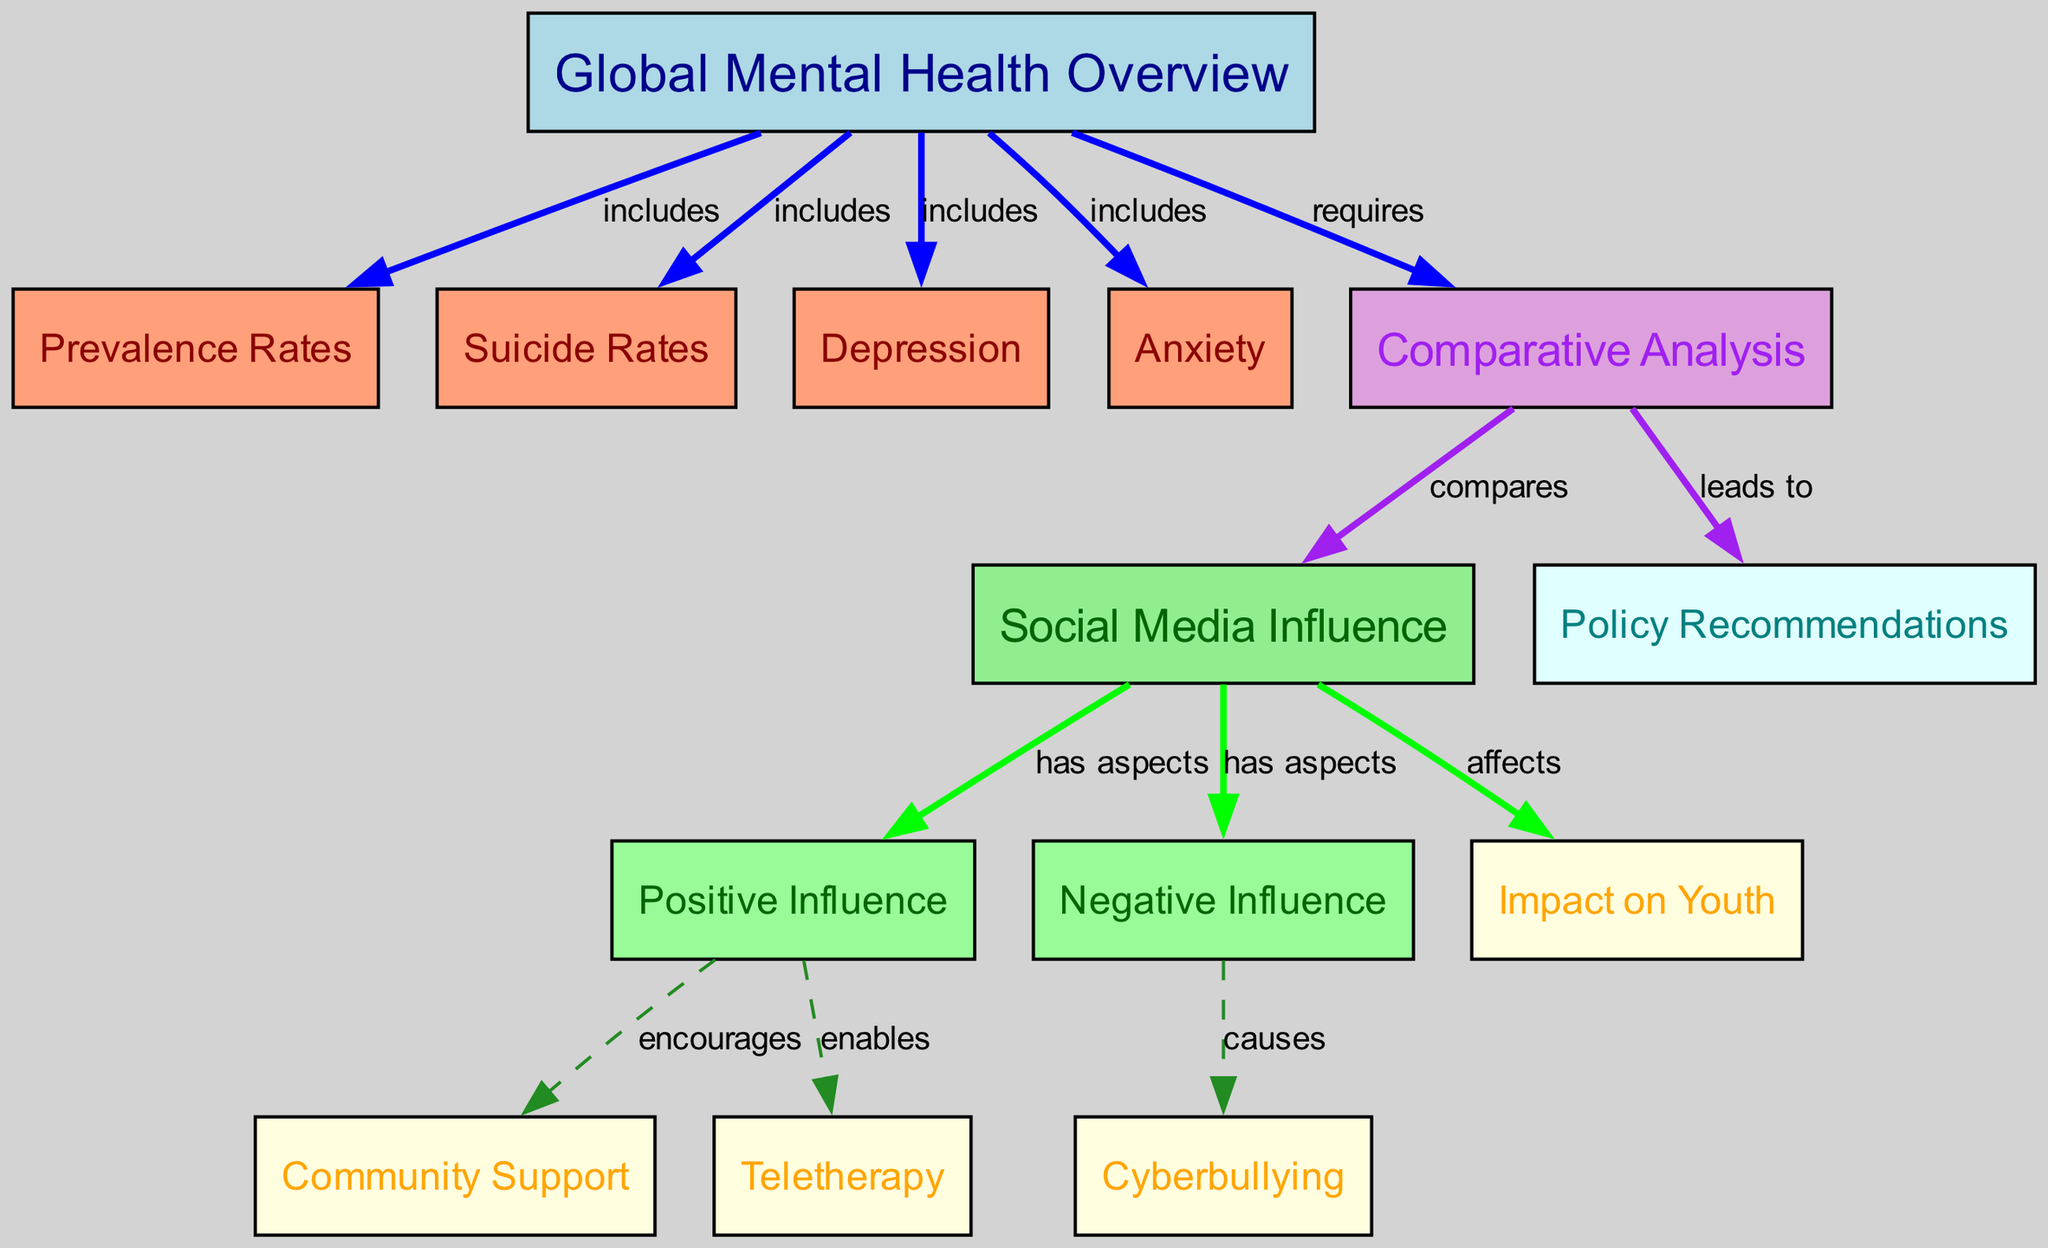What are the included aspects of Global Mental Health Overview? The Global Mental Health Overview node branches out to four specific aspects: Prevalence Rates, Suicide Rates, Depression, and Anxiety. Each of these nodes is connected to the Global Mental Health Overview node with an "includes" label.
Answer: Prevalence Rates, Suicide Rates, Depression, Anxiety How many nodes are present in the diagram? To count the total number of nodes, we simply list the unique nodes presented in the diagram. There are 13 distinct nodes in total.
Answer: 13 What is the edge relationship between Social Media Influence and Positive Influence? The Social Media Influence node has a direct edge labeled "has aspects" that connects it to the Positive Influence node. This indicates the nature of the relationship.
Answer: has aspects Which influence aspect causes Cyberbullying? The Negative Influence node directly connects to the Cyberbullying node with an edge labeled "causes." This relationship indicates that negative influence can lead to cyberbullying incidents.
Answer: Negative Influence What leads to Policy Recommendations in the diagram? The Comparative Analysis node connects to the Policy Recommendations node with an edge labeled "leads to," indicating that a comparative analysis will result in policy recommendations.
Answer: Comparative Analysis What aspect encourages Community Support? The Positive Influence node is connected to the Community Support node with an edge labeled "encourages," representing that positive influence fosters community support initiatives.
Answer: Positive Influence What does the Comparative Analysis compare? The Comparative Analysis node has edges that link to both Social Media Influence and Policy Recommendations, indicating that it involves comparisons relating to social media's effects and the resulting policy suggestions.
Answer: Social Media Influence What impact does Social Media Influence have on Youth? The Social Media Influence node has an edge labeled "affects" that connects to the Youth Impact node, indicating that social media influences are significant for youth segments.
Answer: Youth Impact What type of therapy does Positive Influence enable? Connected to the Positive Influence node is the Teletherapy node, with an edge labeled "enables," indicating that positive influence supports the use of teletherapy options.
Answer: Teletherapy 